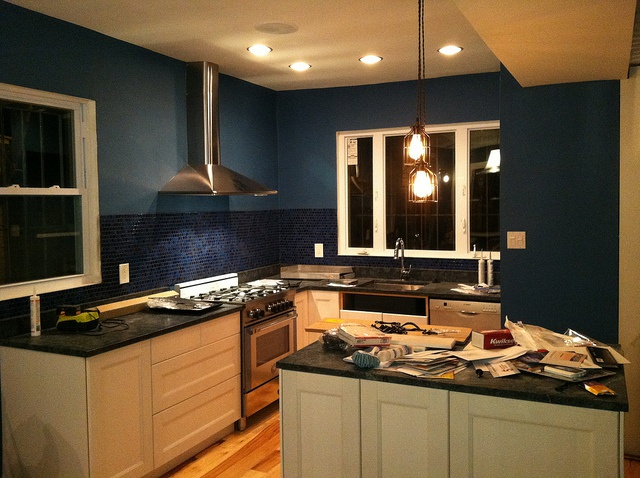Describe the objects in this image and their specific colors. I can see oven in black, maroon, brown, and ivory tones, book in black, tan, and gray tones, book in black, maroon, tan, and brown tones, bottle in black, tan, gray, and olive tones, and sink in black, maroon, and tan tones in this image. 